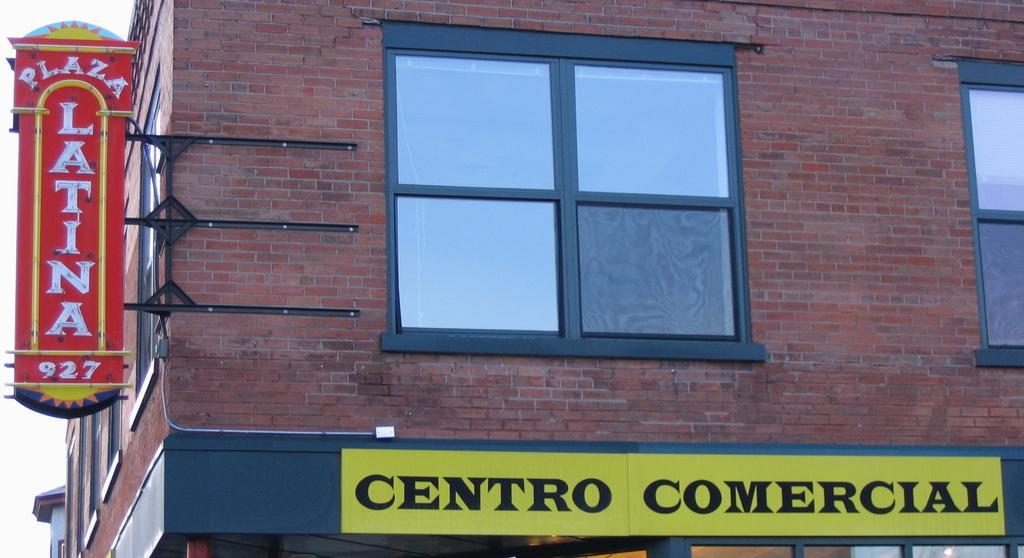Can you describe this image briefly? This is the picture of a building to which there is a window, stand to which there is a board and also the other board which is in yellow color. 